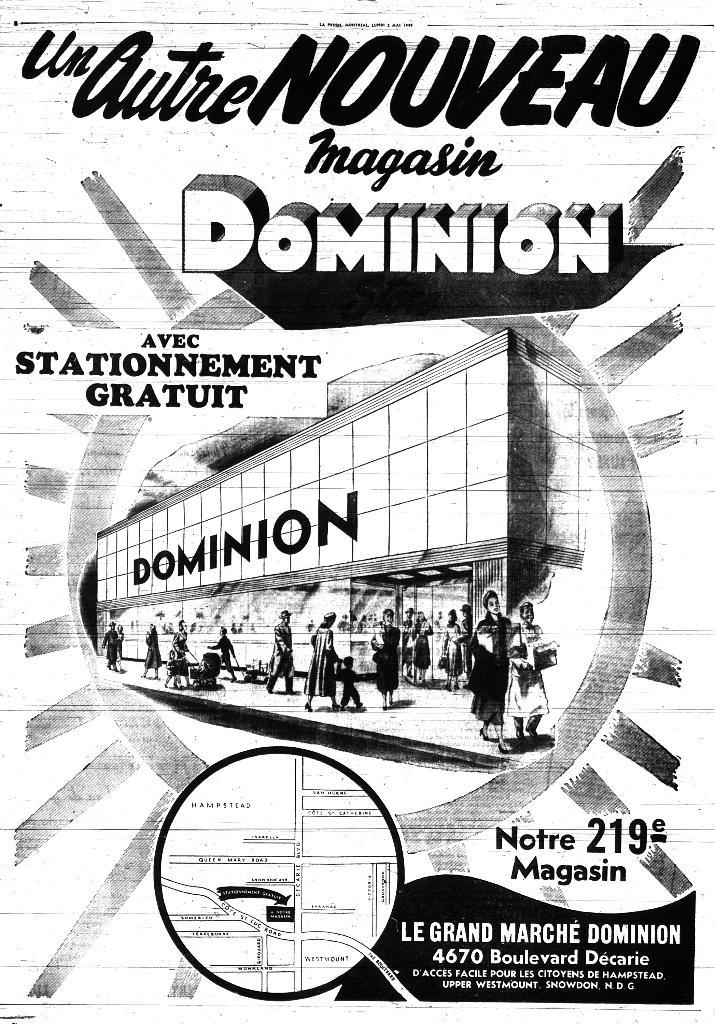<image>
Present a compact description of the photo's key features. a poster advertising a department store called dominion 